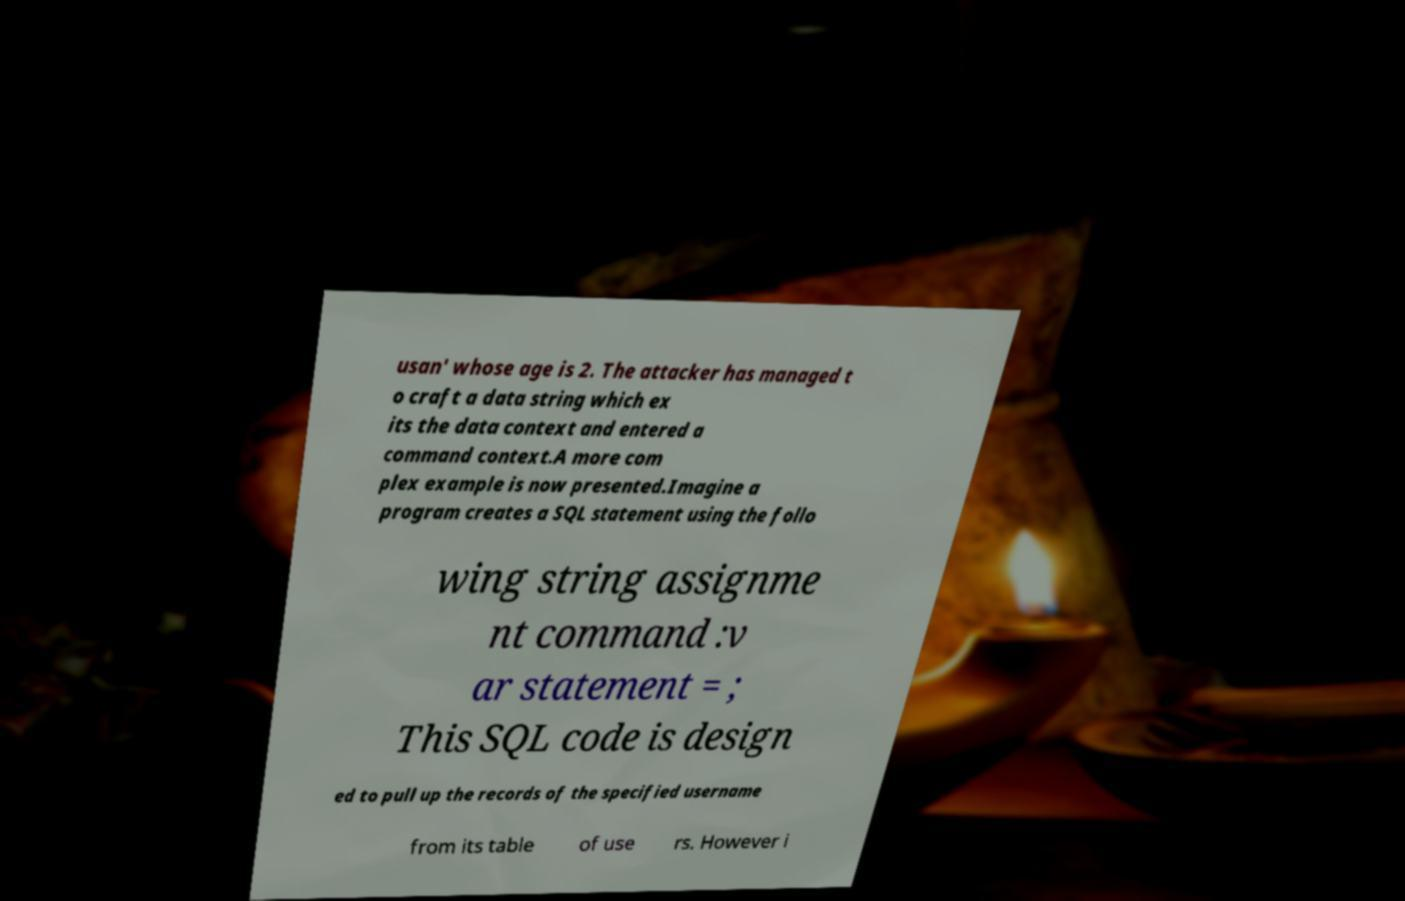What messages or text are displayed in this image? I need them in a readable, typed format. usan' whose age is 2. The attacker has managed t o craft a data string which ex its the data context and entered a command context.A more com plex example is now presented.Imagine a program creates a SQL statement using the follo wing string assignme nt command :v ar statement = ; This SQL code is design ed to pull up the records of the specified username from its table of use rs. However i 